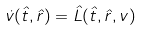Convert formula to latex. <formula><loc_0><loc_0><loc_500><loc_500>\dot { v } ( \hat { t } , \hat { r } ) = \hat { L } ( \hat { t } , \hat { r } , v )</formula> 